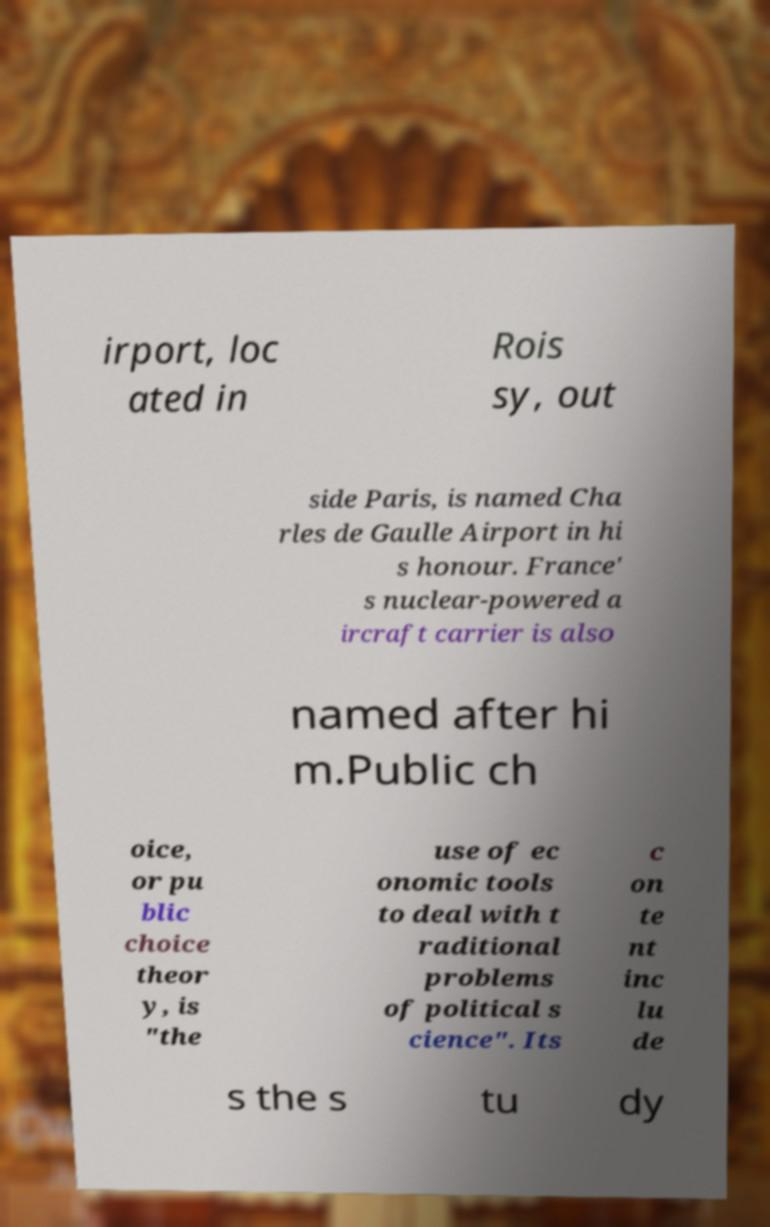There's text embedded in this image that I need extracted. Can you transcribe it verbatim? irport, loc ated in Rois sy, out side Paris, is named Cha rles de Gaulle Airport in hi s honour. France' s nuclear-powered a ircraft carrier is also named after hi m.Public ch oice, or pu blic choice theor y, is "the use of ec onomic tools to deal with t raditional problems of political s cience". Its c on te nt inc lu de s the s tu dy 